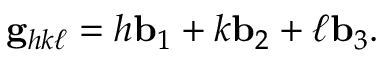Convert formula to latex. <formula><loc_0><loc_0><loc_500><loc_500>g _ { h k \ell } = h b _ { 1 } + k b _ { 2 } + \ell b _ { 3 } .</formula> 